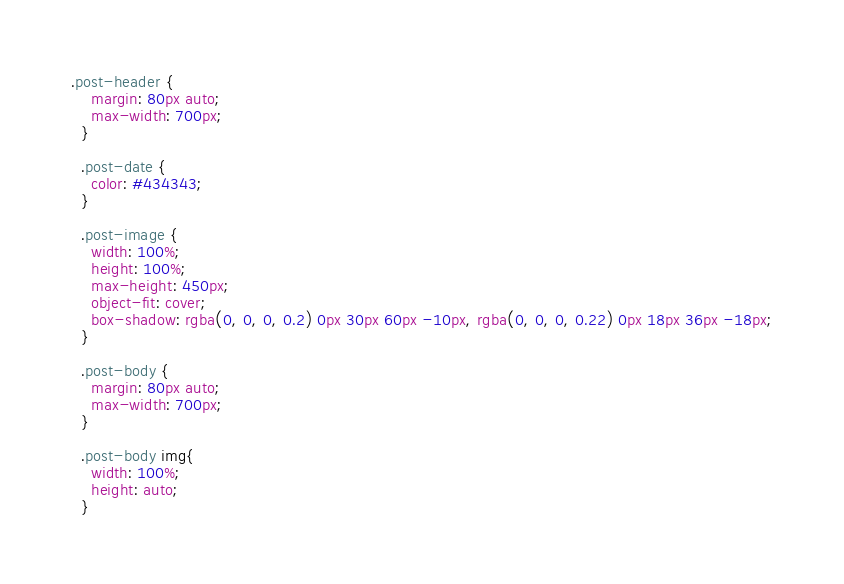Convert code to text. <code><loc_0><loc_0><loc_500><loc_500><_CSS_>.post-header {
    margin: 80px auto;
    max-width: 700px;
  }
  
  .post-date {
    color: #434343;
  }
  
  .post-image {
    width: 100%;
    height: 100%;
    max-height: 450px;
    object-fit: cover;
    box-shadow: rgba(0, 0, 0, 0.2) 0px 30px 60px -10px, rgba(0, 0, 0, 0.22) 0px 18px 36px -18px;
  }
  
  .post-body {
    margin: 80px auto;
    max-width: 700px;
  }
  
  .post-body img{
    width: 100%;
    height: auto;
  }</code> 